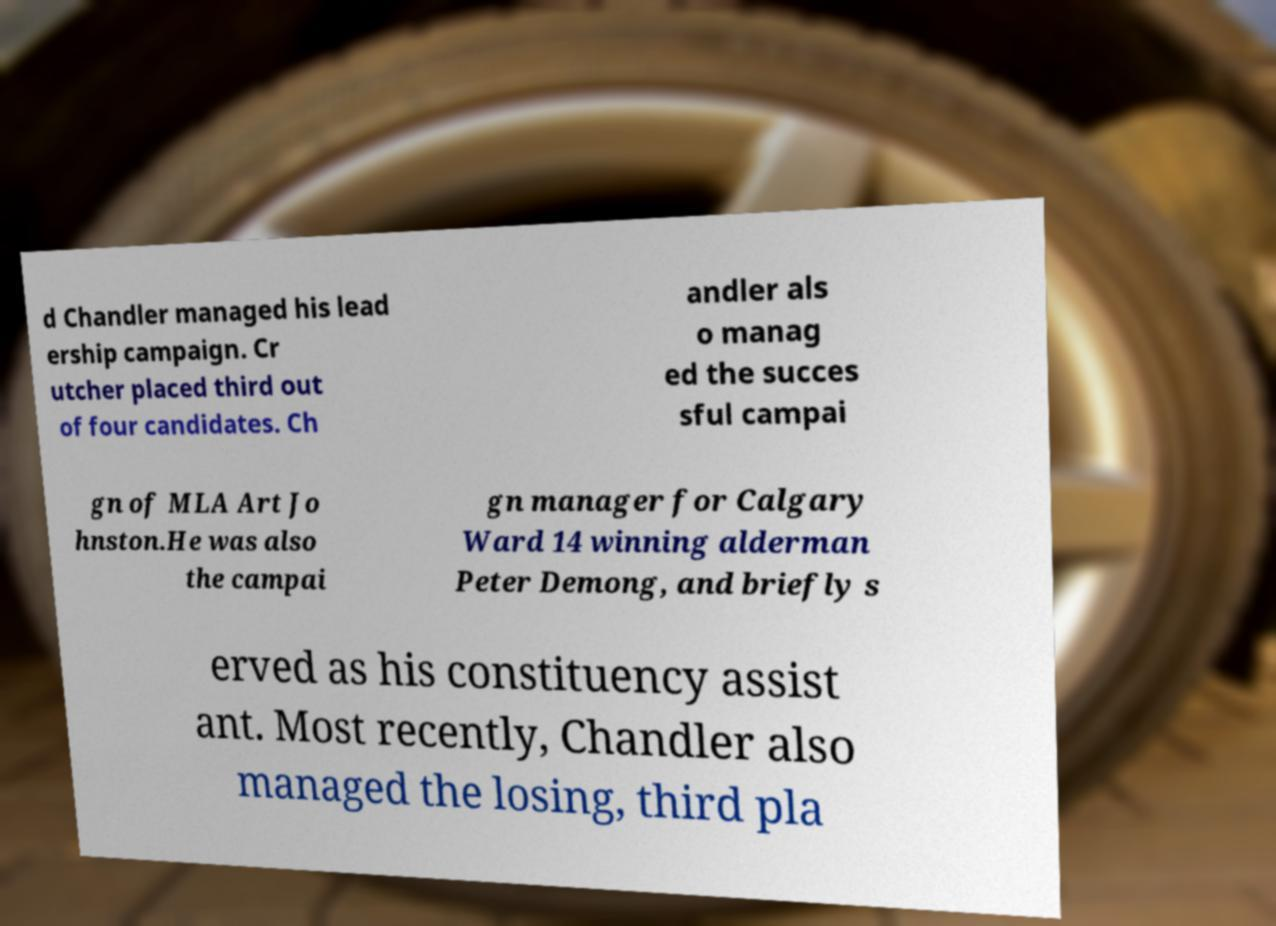For documentation purposes, I need the text within this image transcribed. Could you provide that? d Chandler managed his lead ership campaign. Cr utcher placed third out of four candidates. Ch andler als o manag ed the succes sful campai gn of MLA Art Jo hnston.He was also the campai gn manager for Calgary Ward 14 winning alderman Peter Demong, and briefly s erved as his constituency assist ant. Most recently, Chandler also managed the losing, third pla 